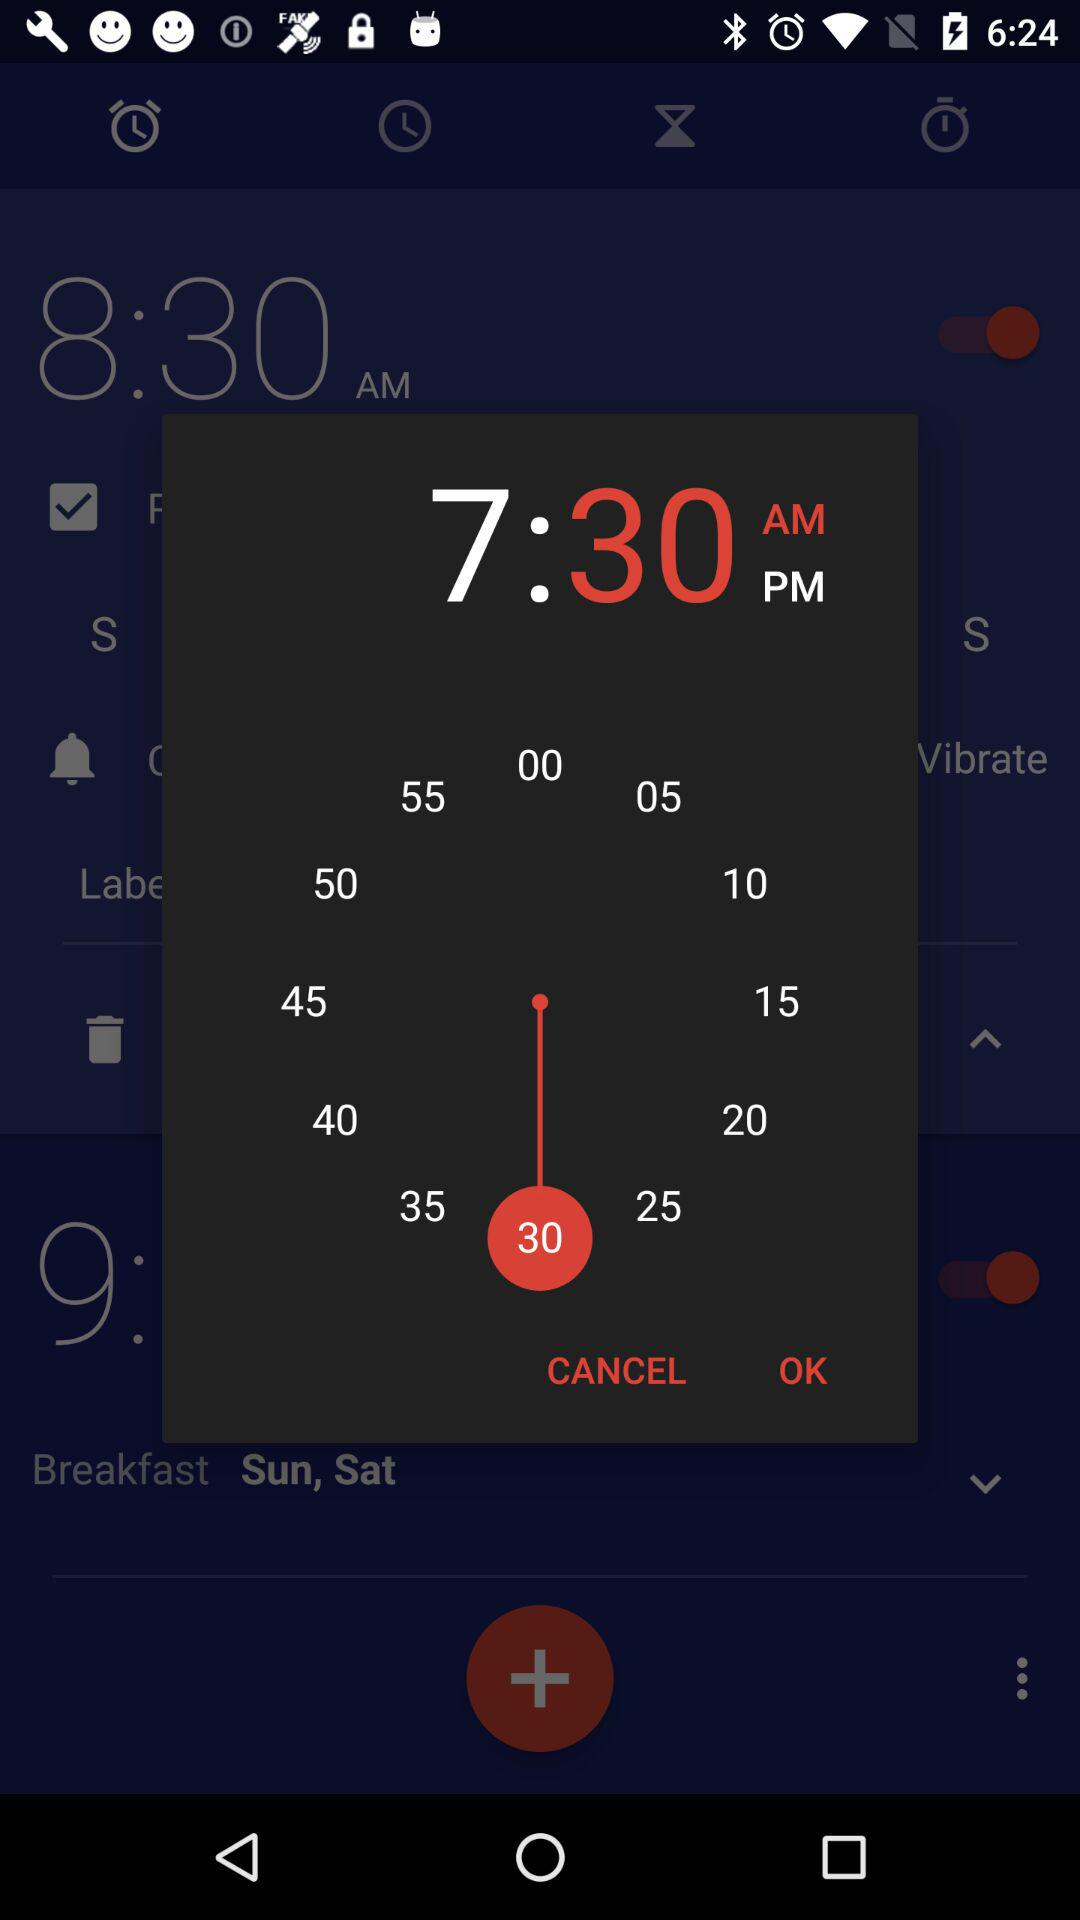What is the set time? The set time is 7:30 AM. 